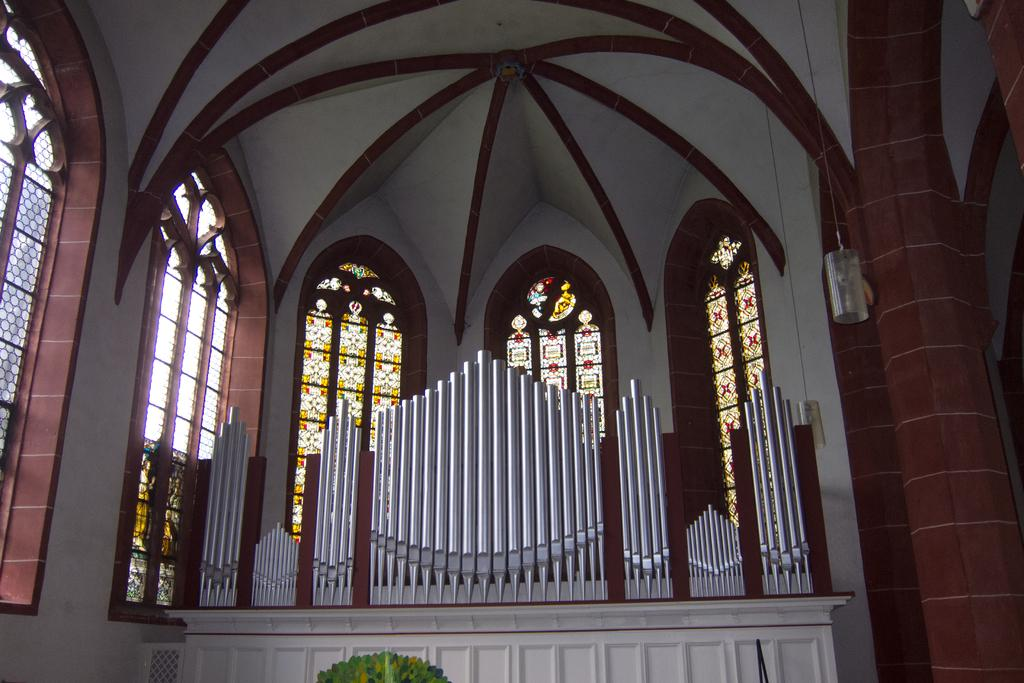What type of location is depicted in the image? The image shows an inside view of a house. What architectural feature can be seen in the image? There is an arch in the image. What allows natural light to enter the house in the image? There are windows in the image. What structural elements are present in the image? There are walls in the image. Can you see a kitten playing with a pail of rice in the image? No, there is no kitten or pail of rice present in the image. 